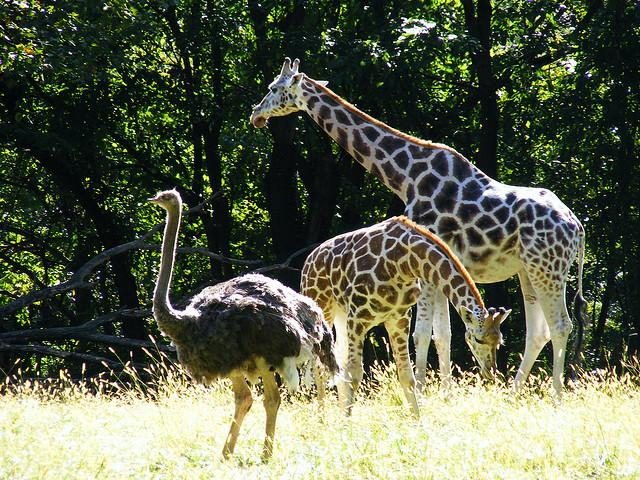How many giraffes are standing around the forest near the ostrich? two 